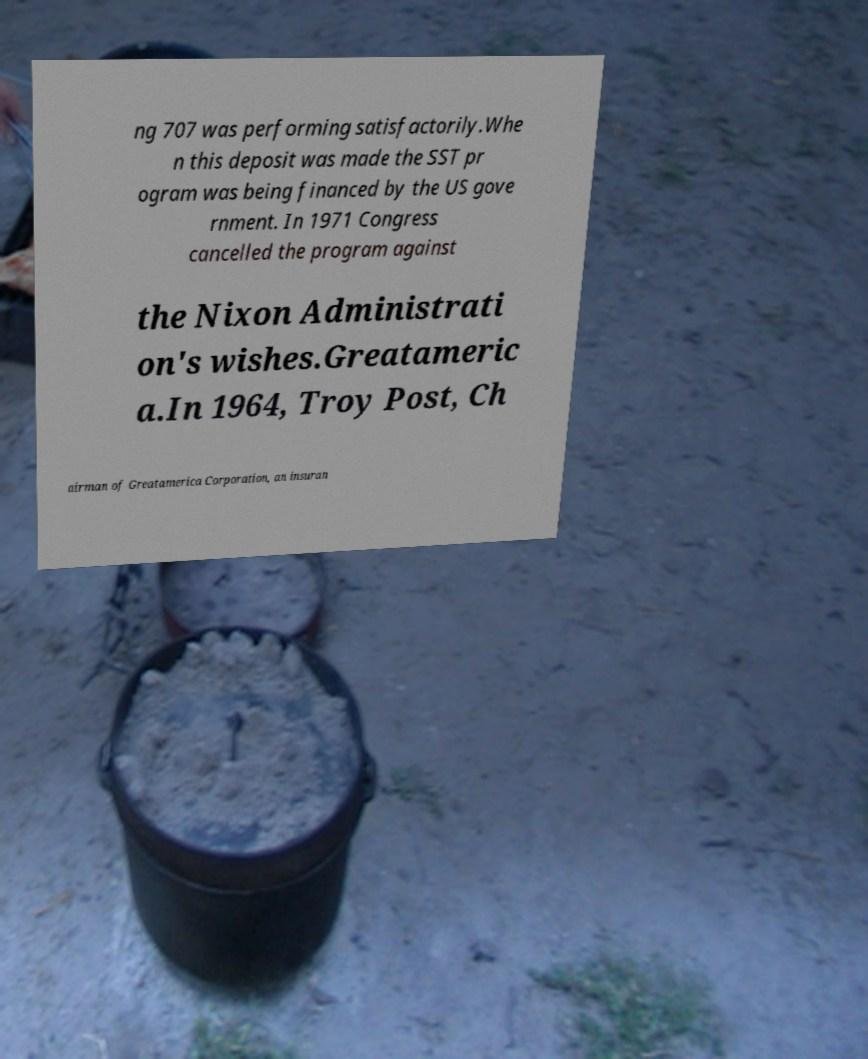Could you extract and type out the text from this image? ng 707 was performing satisfactorily.Whe n this deposit was made the SST pr ogram was being financed by the US gove rnment. In 1971 Congress cancelled the program against the Nixon Administrati on's wishes.Greatameric a.In 1964, Troy Post, Ch airman of Greatamerica Corporation, an insuran 